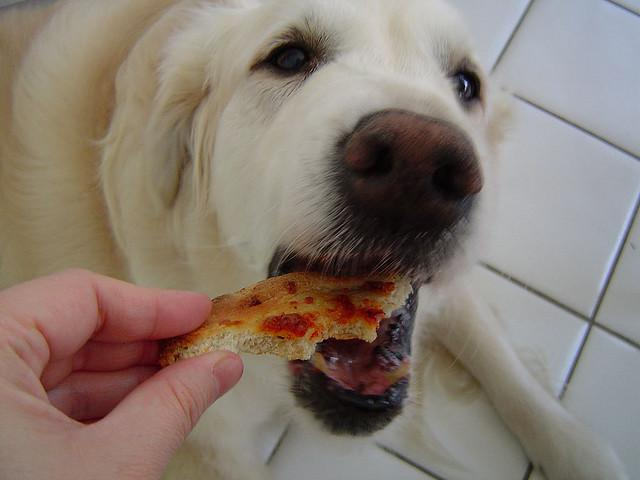What is the dog chowing down on? Please explain your reasoning. pizza. The dog is being fed a piece of pizza by its owner. 